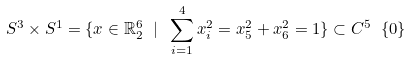<formula> <loc_0><loc_0><loc_500><loc_500>S ^ { 3 } \times S ^ { 1 } = \{ x \in \mathbb { R } ^ { 6 } _ { 2 } \ | \ \sum ^ { 4 } _ { i = 1 } x ^ { 2 } _ { i } = x ^ { 2 } _ { 5 } + x ^ { 2 } _ { 6 } = 1 \} \subset C ^ { 5 } \ \{ 0 \}</formula> 